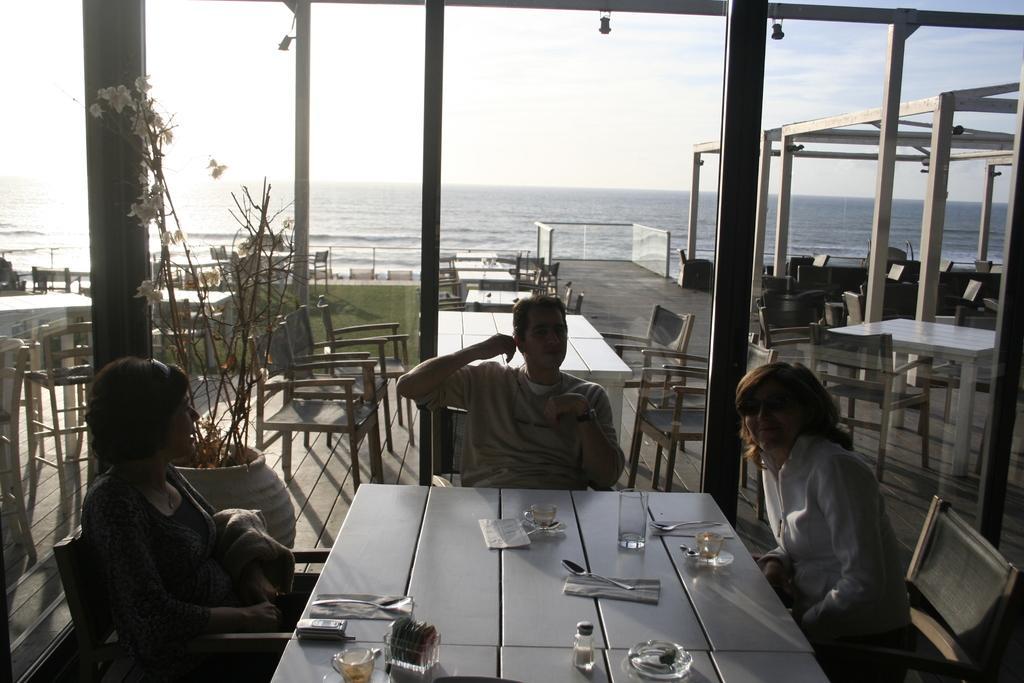Describe this image in one or two sentences. In the picture we can see a three people sitting on a chairs near the table two are women and one is men, on the table we can see some glasses, tissues, spoons and cups, in the background we can see some tables, chairs, plants,grass and a ocean with sky. 